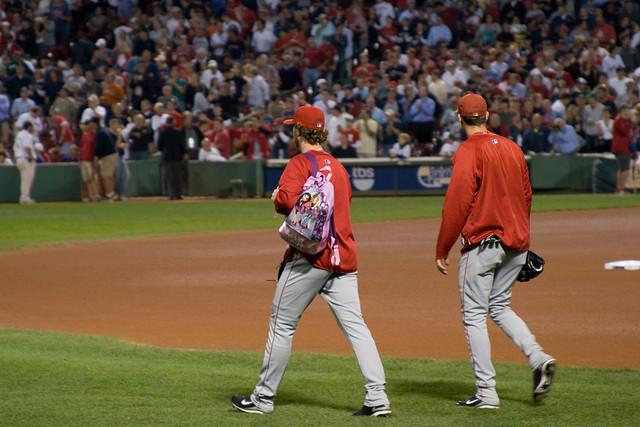What Color is the man's uniform?
Keep it brief. Red. Are the bleachers full?
Short answer required. Yes. What is the man holding?
Answer briefly. Bag. How many people are on the field?
Concise answer only. 2. Are both people walking?
Concise answer only. Yes. How many players are on the field?
Quick response, please. 2. Is this the winning team?
Concise answer only. No. Are they both on the same team?
Answer briefly. Yes. Is the game over?
Quick response, please. Yes. 